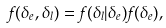<formula> <loc_0><loc_0><loc_500><loc_500>f ( \delta _ { e } , \delta _ { l } ) = f ( \delta _ { l } | \delta _ { e } ) f ( \delta _ { e } ) ,</formula> 